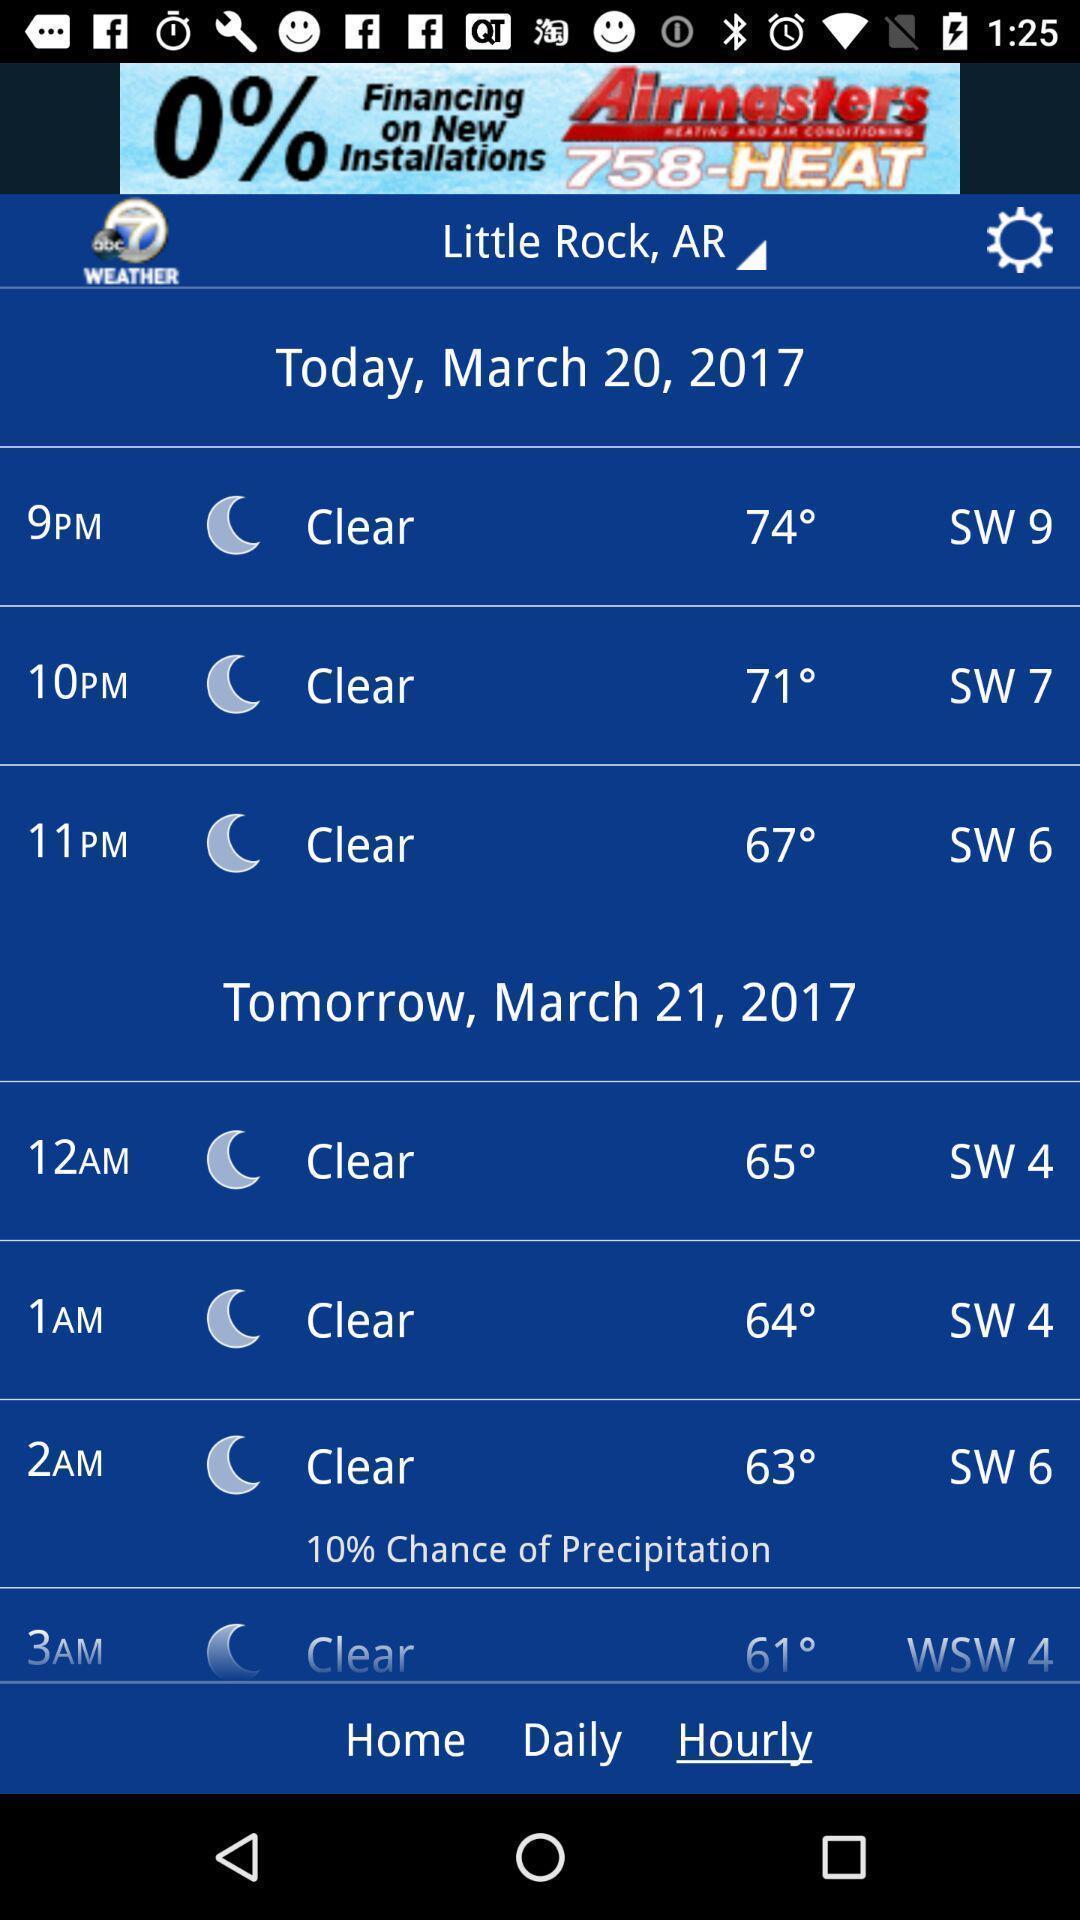Describe the visual elements of this screenshot. Screen shows hourly updates in weather forecasting application. 